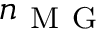<formula> <loc_0><loc_0><loc_500><loc_500>n _ { M G }</formula> 